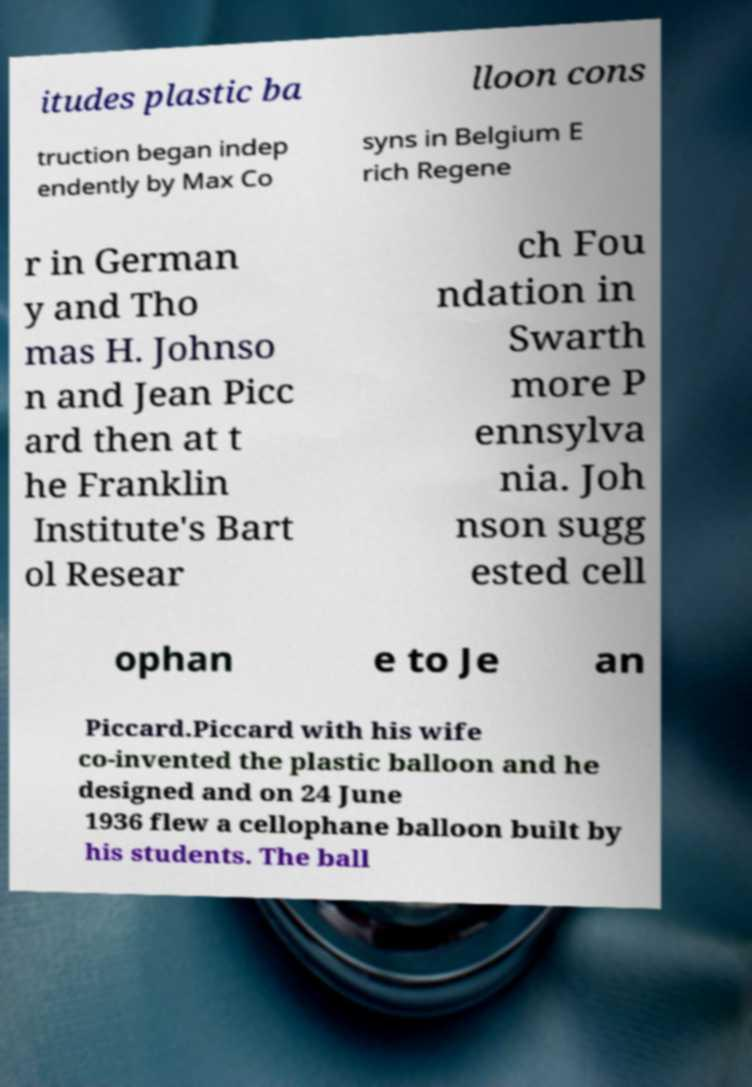For documentation purposes, I need the text within this image transcribed. Could you provide that? itudes plastic ba lloon cons truction began indep endently by Max Co syns in Belgium E rich Regene r in German y and Tho mas H. Johnso n and Jean Picc ard then at t he Franklin Institute's Bart ol Resear ch Fou ndation in Swarth more P ennsylva nia. Joh nson sugg ested cell ophan e to Je an Piccard.Piccard with his wife co-invented the plastic balloon and he designed and on 24 June 1936 flew a cellophane balloon built by his students. The ball 